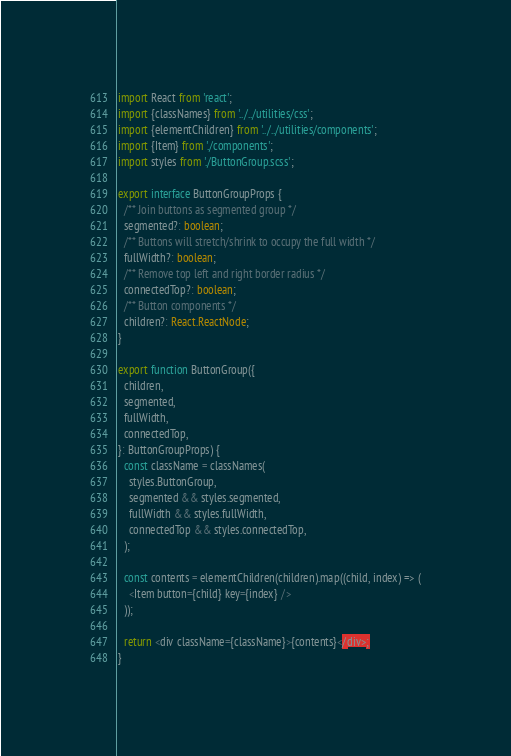<code> <loc_0><loc_0><loc_500><loc_500><_TypeScript_>import React from 'react';
import {classNames} from '../../utilities/css';
import {elementChildren} from '../../utilities/components';
import {Item} from './components';
import styles from './ButtonGroup.scss';

export interface ButtonGroupProps {
  /** Join buttons as segmented group */
  segmented?: boolean;
  /** Buttons will stretch/shrink to occupy the full width */
  fullWidth?: boolean;
  /** Remove top left and right border radius */
  connectedTop?: boolean;
  /** Button components */
  children?: React.ReactNode;
}

export function ButtonGroup({
  children,
  segmented,
  fullWidth,
  connectedTop,
}: ButtonGroupProps) {
  const className = classNames(
    styles.ButtonGroup,
    segmented && styles.segmented,
    fullWidth && styles.fullWidth,
    connectedTop && styles.connectedTop,
  );

  const contents = elementChildren(children).map((child, index) => (
    <Item button={child} key={index} />
  ));

  return <div className={className}>{contents}</div>;
}
</code> 